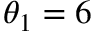Convert formula to latex. <formula><loc_0><loc_0><loc_500><loc_500>\theta _ { 1 } = 6</formula> 